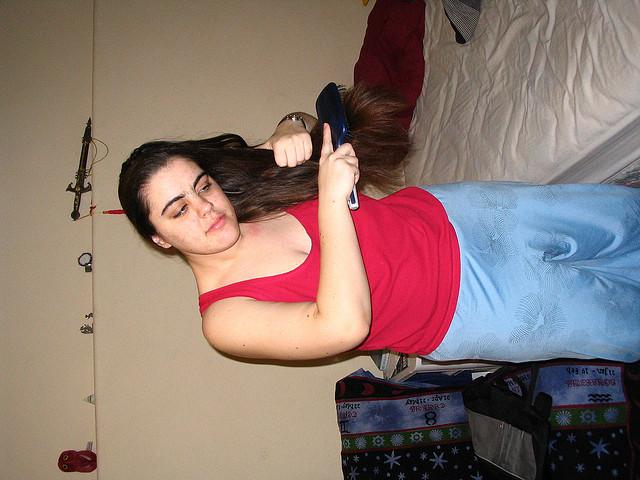Is the woman excited?
Quick response, please. No. What does the bed need?
Be succinct. Sheets. Is the woman going to bed?
Short answer required. Yes. 